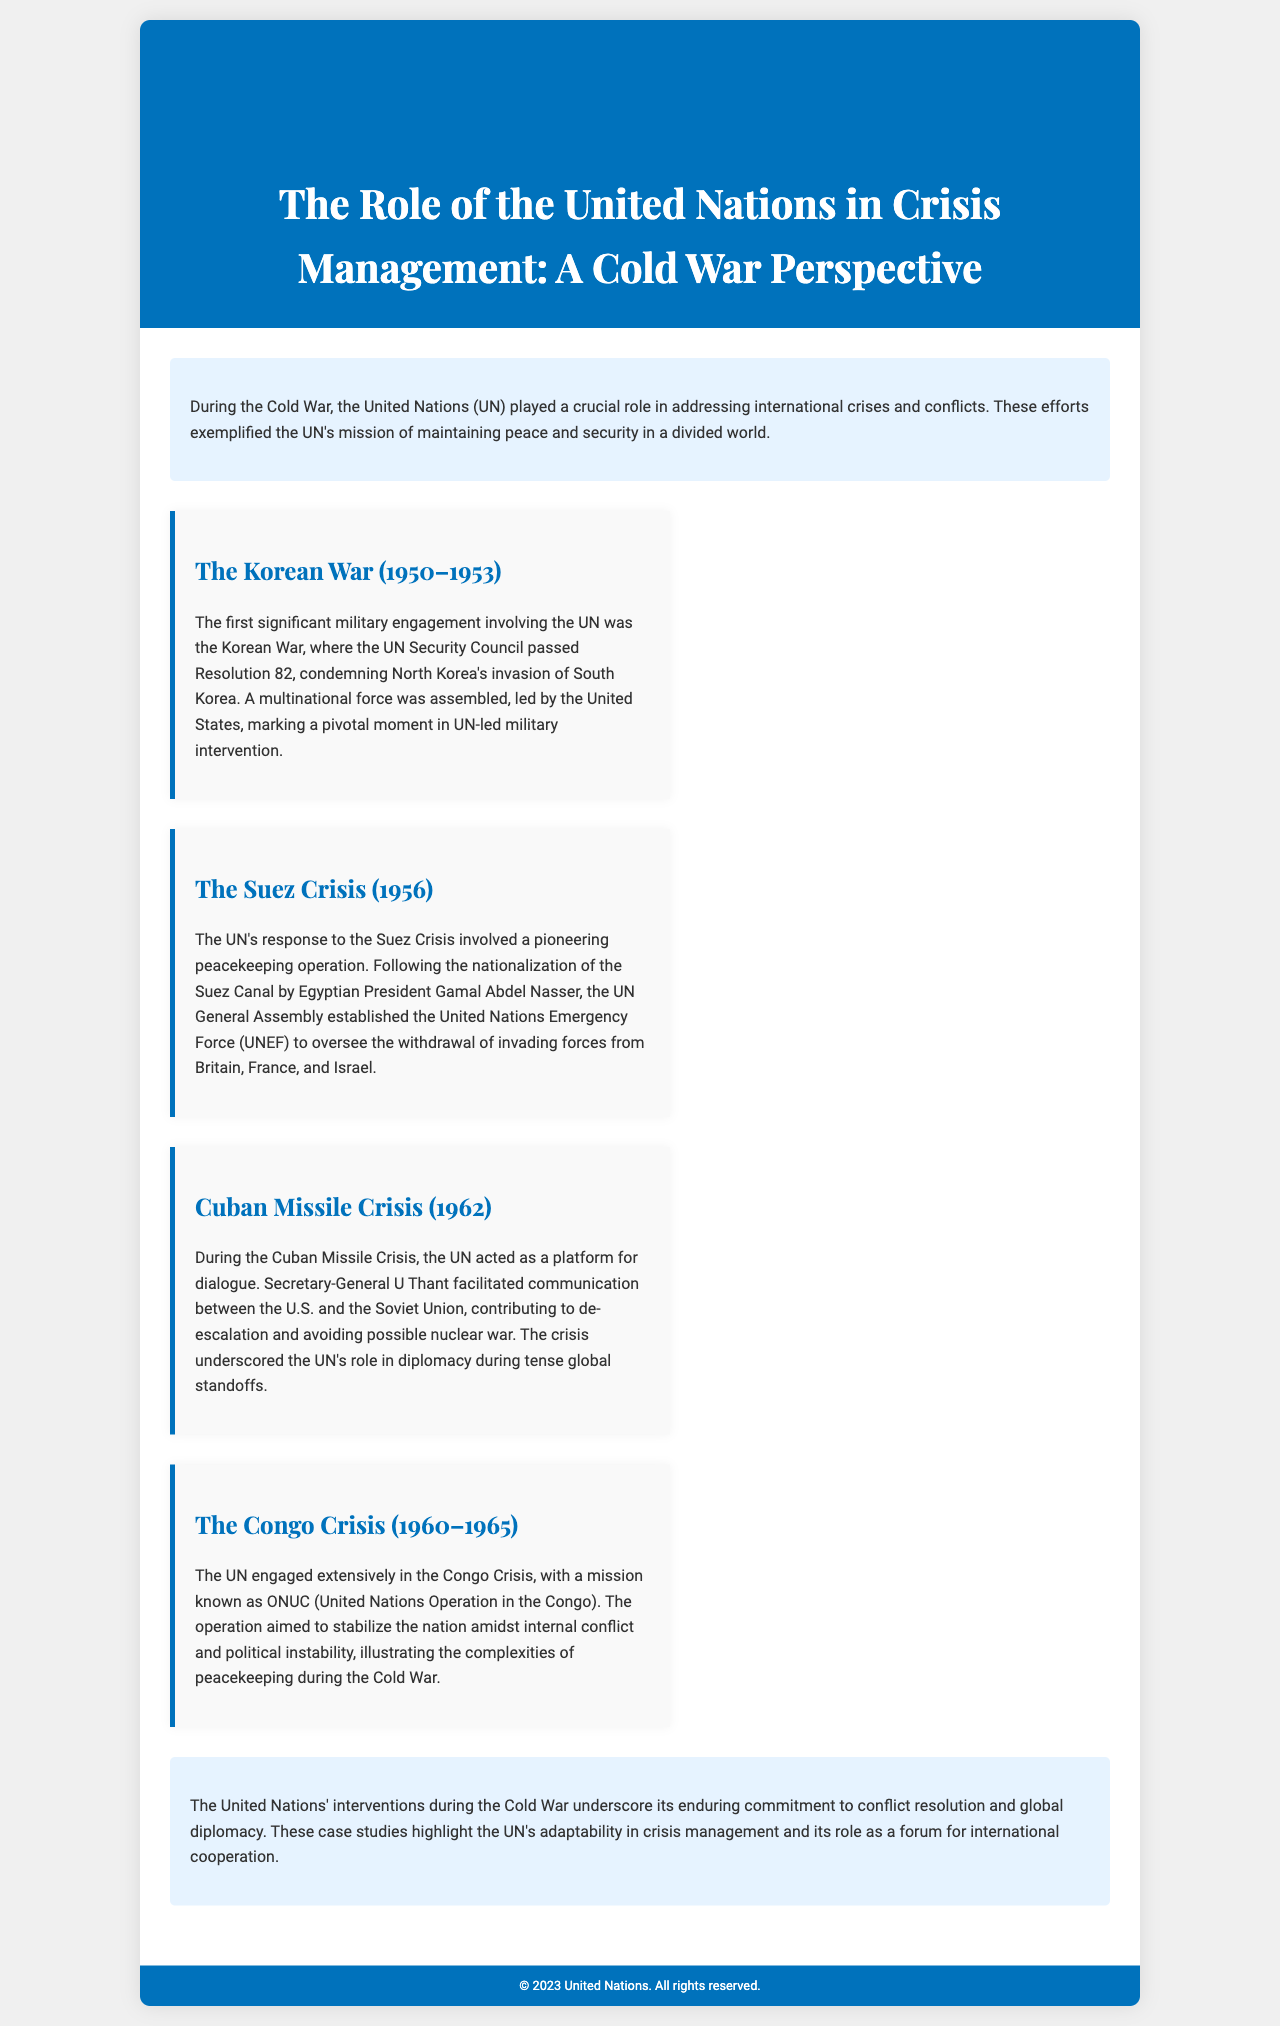What was the first significant military engagement involving the UN? The document states that the Korean War was the first significant military engagement involving the UN.
Answer: Korean War What year did the Suez Crisis occur? The document mentions the Suez Crisis occurred in 1956.
Answer: 1956 Who led the multinational force during the Korean War? The document identifies the United States as the leader of the multinational force during the Korean War.
Answer: United States What operation was established during the Suez Crisis? The United Nations Emergency Force (UNEF) was established during the Suez Crisis, as stated in the document.
Answer: United Nations Emergency Force Which UN Secretary-General facilitated dialogue during the Cuban Missile Crisis? The document mentions U Thant as the UN Secretary-General who facilitated dialogue during the Cuban Missile Crisis.
Answer: U Thant What significant role did the UN play in the Congo Crisis? The document explains that the UN engaged extensively to stabilize the nation amidst internal conflict and political instability during the Congo Crisis.
Answer: Stabilization What is the main purpose of the brochure? The brochure’s main purpose is to detail the UN's role in crisis management during the Cold War.
Answer: Crisis management How many case studies are presented in this brochure? The document lists four specific case studies regarding the UN's interventions during the Cold War.
Answer: Four What is highlighted as a key aspect of the UN’s role in conflict resolution? The document emphasizes the UN's adaptability in crisis management and its role in international cooperation.
Answer: Adaptability in crisis management 